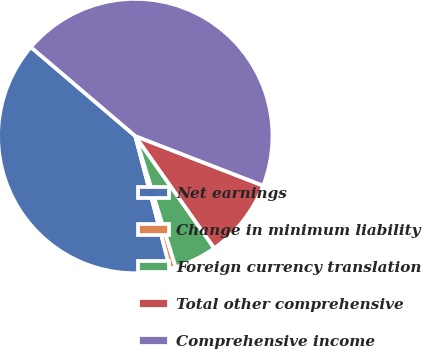<chart> <loc_0><loc_0><loc_500><loc_500><pie_chart><fcel>Net earnings<fcel>Change in minimum liability<fcel>Foreign currency translation<fcel>Total other comprehensive<fcel>Comprehensive income<nl><fcel>40.31%<fcel>0.67%<fcel>5.01%<fcel>9.35%<fcel>44.65%<nl></chart> 